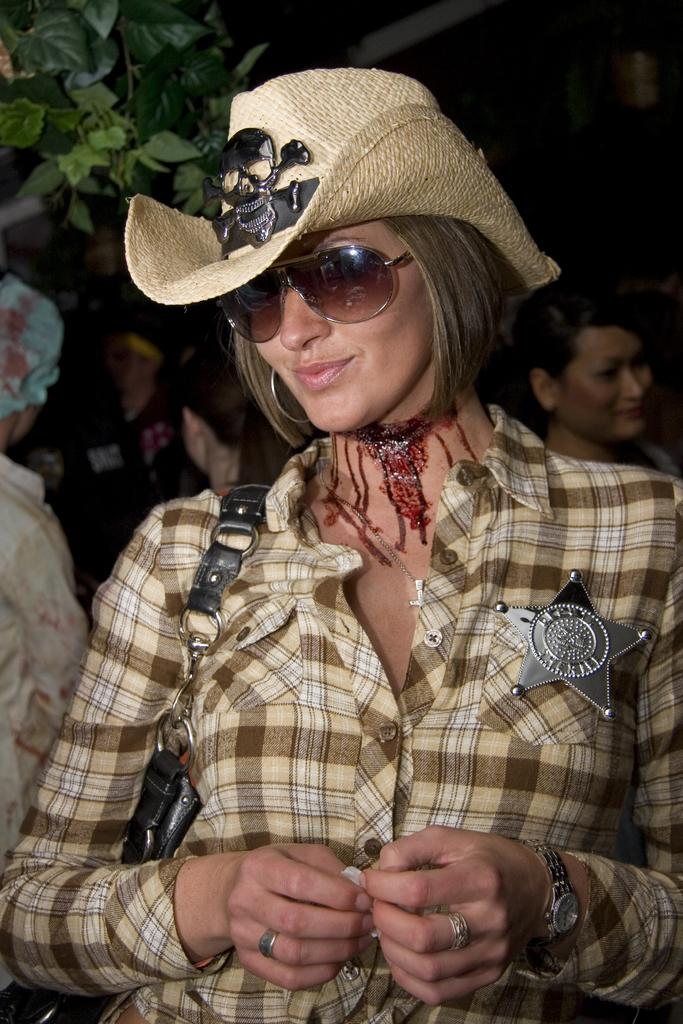What can be seen in the image? There is a group of people in the image. Can you describe any objects or plants in the image? Yes, there is a plant in the image. Who is the most prominent person in the group? A woman is standing in the front of the group. What is the woman wearing on her head? The woman is wearing a cream-colored hat. What is the woman holding in her hand? The woman is holding a black-colored bag. What appliance is being used by the woman in the image? There is no appliance visible in the image. What day of the week is it in the image? The day of the week is not mentioned or depicted in the image. 